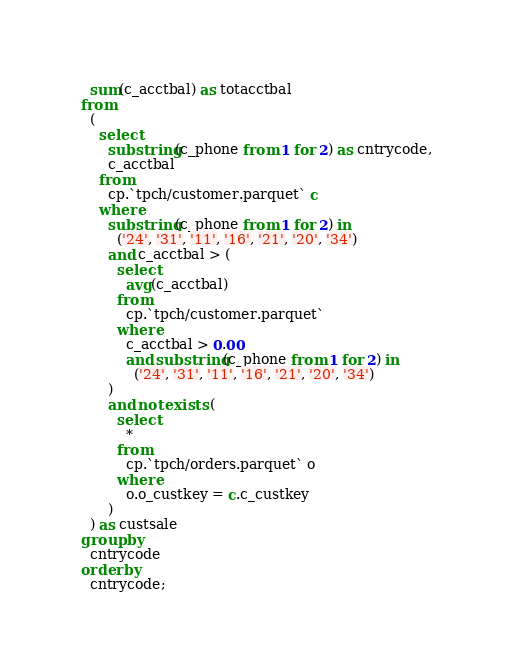Convert code to text. <code><loc_0><loc_0><loc_500><loc_500><_SQL_>  sum(c_acctbal) as totacctbal
from
  (
    select
      substring(c_phone from 1 for 2) as cntrycode,
      c_acctbal
    from
      cp.`tpch/customer.parquet` c
    where
      substring(c_phone from 1 for 2) in
        ('24', '31', '11', '16', '21', '20', '34')
      and c_acctbal > (
        select
          avg(c_acctbal)
        from
          cp.`tpch/customer.parquet`
        where
          c_acctbal > 0.00
          and substring(c_phone from 1 for 2) in
            ('24', '31', '11', '16', '21', '20', '34')
      )
      and not exists (
        select
          *
        from
          cp.`tpch/orders.parquet` o
        where
          o.o_custkey = c.c_custkey
      )
  ) as custsale
group by
  cntrycode
order by
  cntrycode;
</code> 